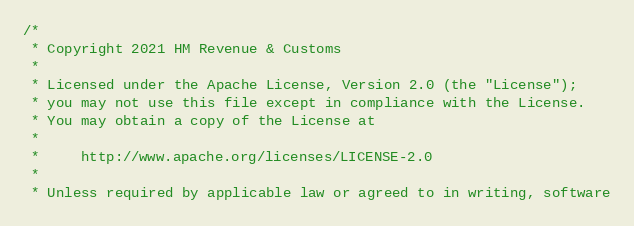<code> <loc_0><loc_0><loc_500><loc_500><_Scala_>/*
 * Copyright 2021 HM Revenue & Customs
 *
 * Licensed under the Apache License, Version 2.0 (the "License");
 * you may not use this file except in compliance with the License.
 * You may obtain a copy of the License at
 *
 *     http://www.apache.org/licenses/LICENSE-2.0
 *
 * Unless required by applicable law or agreed to in writing, software</code> 